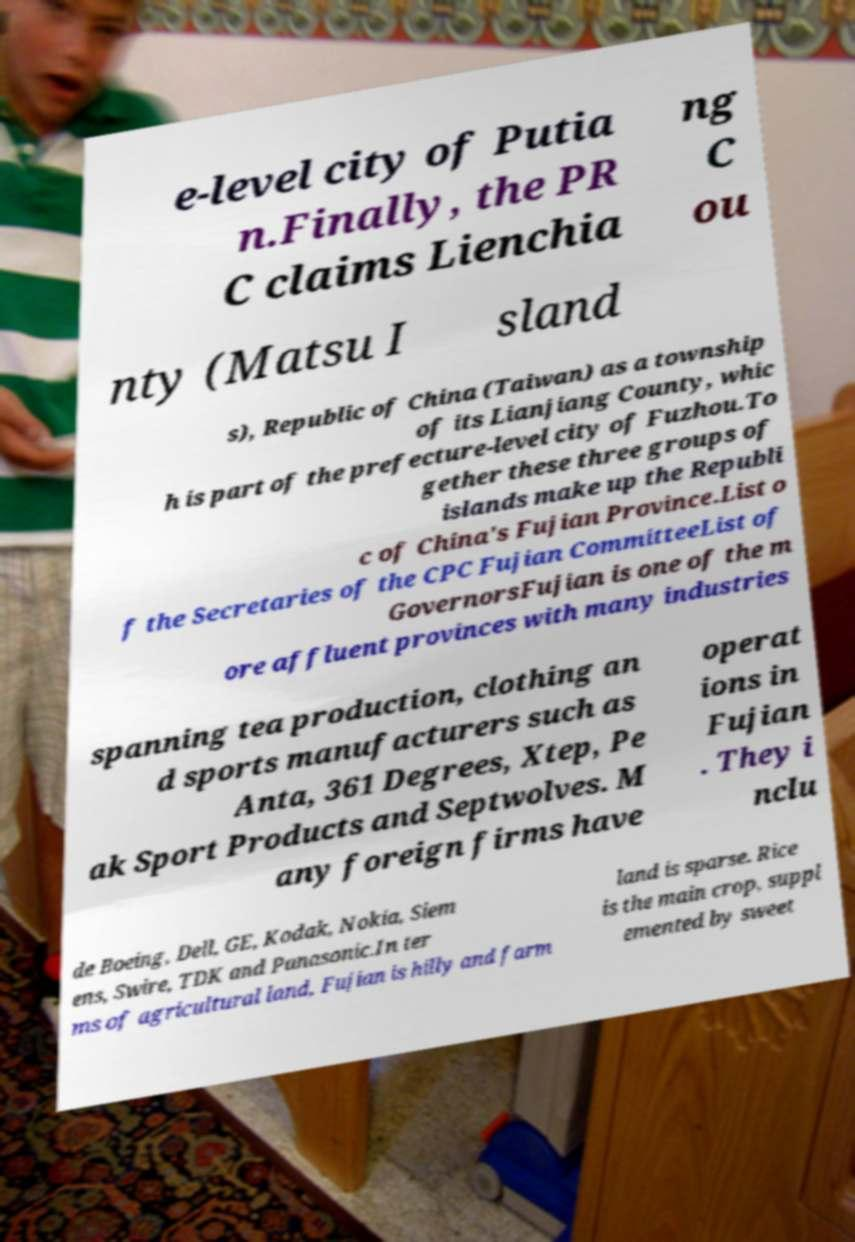Can you accurately transcribe the text from the provided image for me? e-level city of Putia n.Finally, the PR C claims Lienchia ng C ou nty (Matsu I sland s), Republic of China (Taiwan) as a township of its Lianjiang County, whic h is part of the prefecture-level city of Fuzhou.To gether these three groups of islands make up the Republi c of China's Fujian Province.List o f the Secretaries of the CPC Fujian CommitteeList of GovernorsFujian is one of the m ore affluent provinces with many industries spanning tea production, clothing an d sports manufacturers such as Anta, 361 Degrees, Xtep, Pe ak Sport Products and Septwolves. M any foreign firms have operat ions in Fujian . They i nclu de Boeing, Dell, GE, Kodak, Nokia, Siem ens, Swire, TDK and Panasonic.In ter ms of agricultural land, Fujian is hilly and farm land is sparse. Rice is the main crop, suppl emented by sweet 